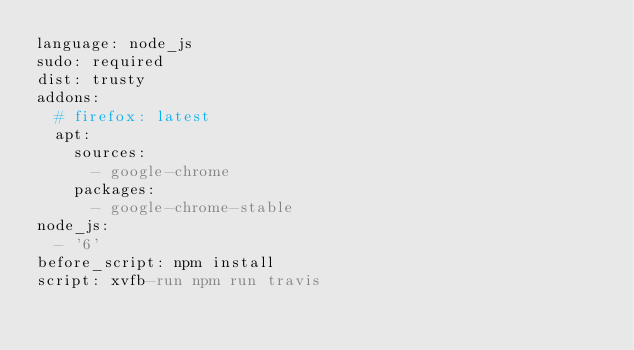Convert code to text. <code><loc_0><loc_0><loc_500><loc_500><_YAML_>language: node_js
sudo: required
dist: trusty
addons:
  # firefox: latest
  apt:
    sources:
      - google-chrome
    packages:
      - google-chrome-stable
node_js:
  - '6'
before_script: npm install
script: xvfb-run npm run travis
</code> 